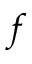<formula> <loc_0><loc_0><loc_500><loc_500>f</formula> 